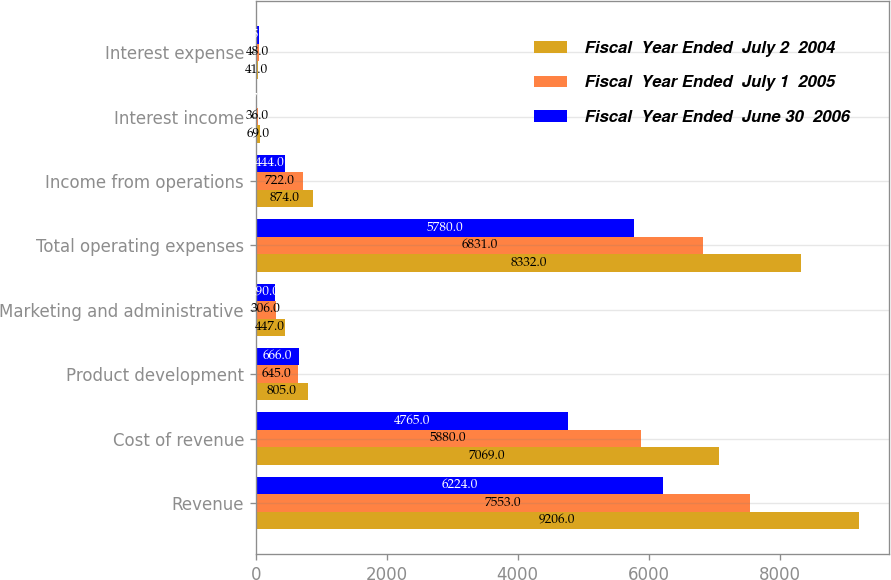<chart> <loc_0><loc_0><loc_500><loc_500><stacked_bar_chart><ecel><fcel>Revenue<fcel>Cost of revenue<fcel>Product development<fcel>Marketing and administrative<fcel>Total operating expenses<fcel>Income from operations<fcel>Interest income<fcel>Interest expense<nl><fcel>Fiscal  Year Ended  July 2  2004<fcel>9206<fcel>7069<fcel>805<fcel>447<fcel>8332<fcel>874<fcel>69<fcel>41<nl><fcel>Fiscal  Year Ended  July 1  2005<fcel>7553<fcel>5880<fcel>645<fcel>306<fcel>6831<fcel>722<fcel>36<fcel>48<nl><fcel>Fiscal  Year Ended  June 30  2006<fcel>6224<fcel>4765<fcel>666<fcel>290<fcel>5780<fcel>444<fcel>17<fcel>45<nl></chart> 